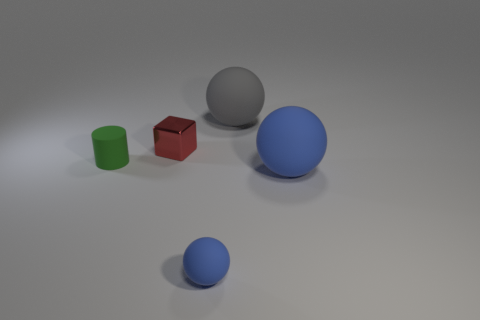What number of other objects are the same color as the tiny ball?
Your response must be concise. 1. How many other small red cubes are the same material as the red block?
Give a very brief answer. 0. Are the blue object that is to the right of the small blue matte sphere and the small sphere made of the same material?
Your response must be concise. Yes. Are there the same number of green matte objects that are on the right side of the small green cylinder and spheres?
Make the answer very short. No. The red metal object is what size?
Ensure brevity in your answer.  Small. What is the material of the other sphere that is the same color as the tiny matte sphere?
Provide a short and direct response. Rubber. What number of objects have the same color as the tiny matte ball?
Offer a terse response. 1. Does the red block have the same size as the green object?
Offer a terse response. Yes. What is the size of the blue object that is on the left side of the big matte ball to the left of the large blue matte ball?
Keep it short and to the point. Small. There is a cylinder; is it the same color as the large matte ball behind the tiny green rubber object?
Offer a very short reply. No. 